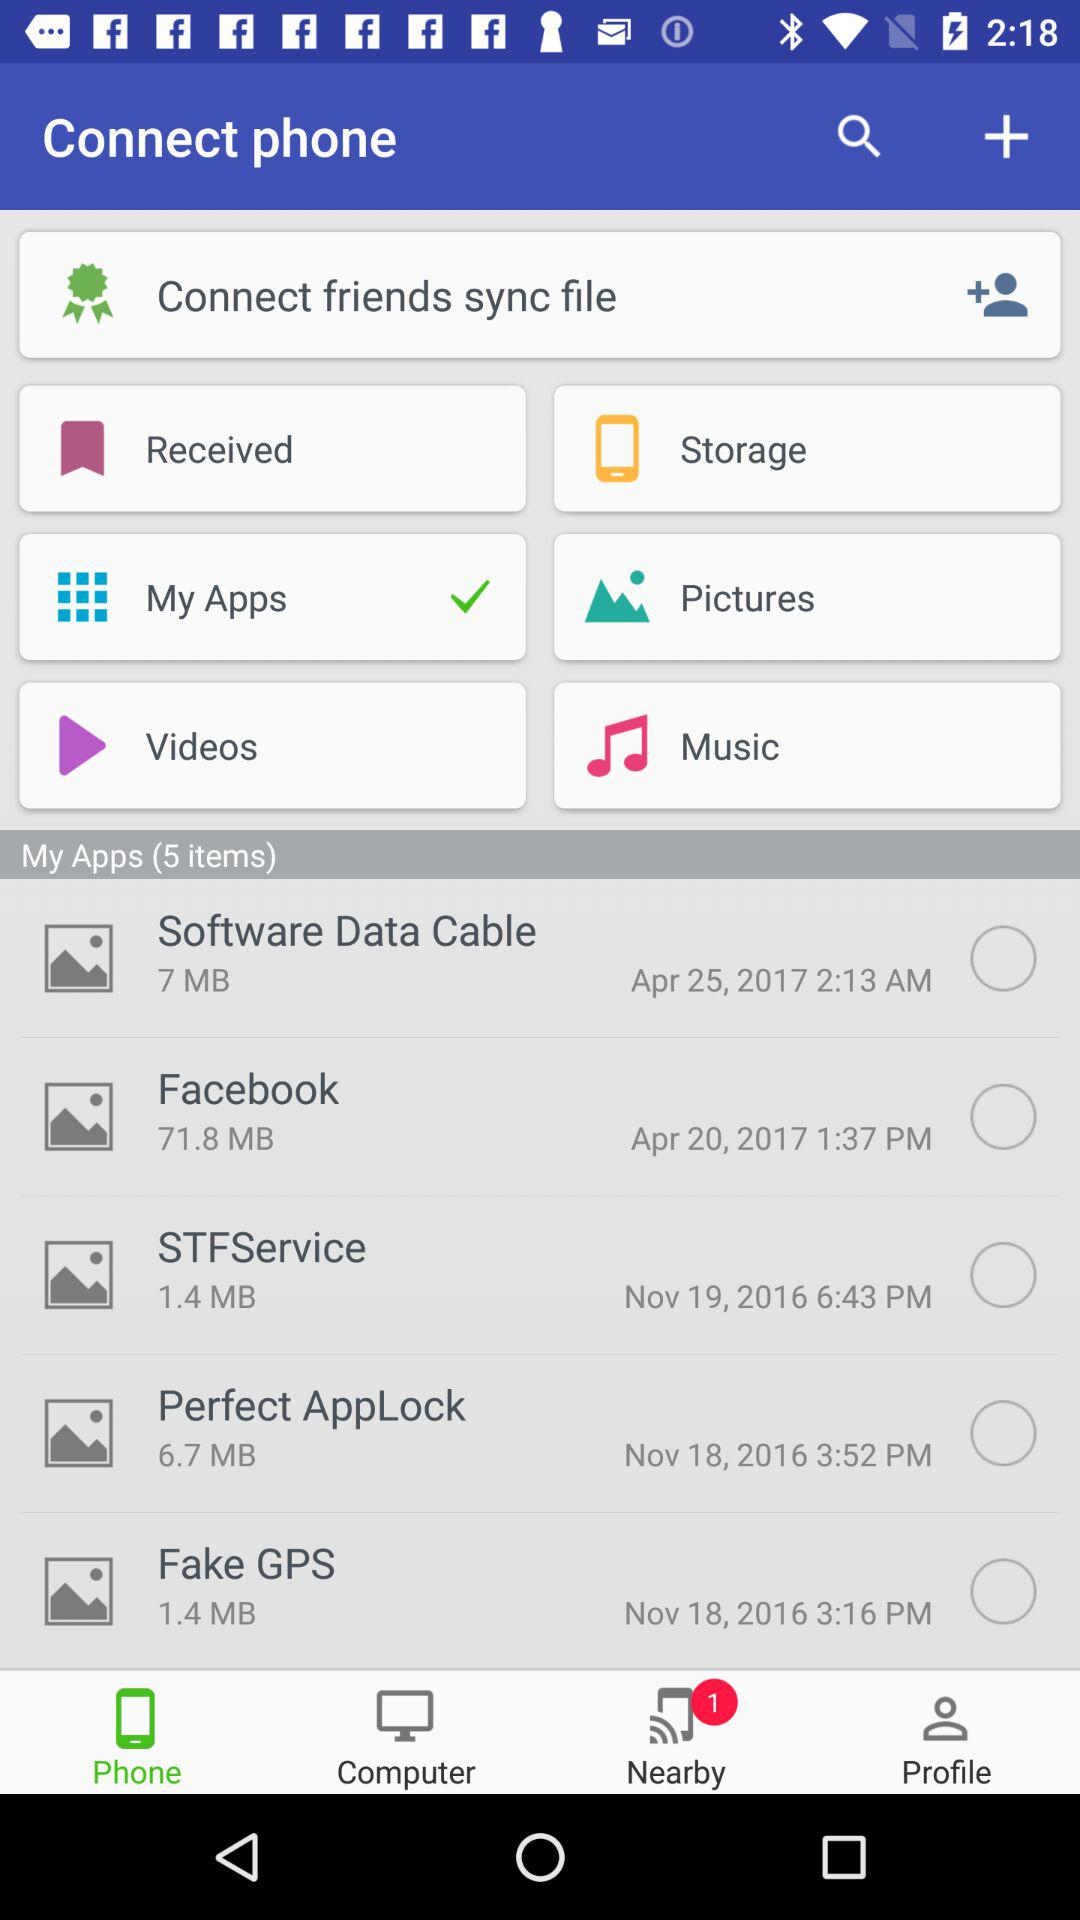How many apps are there in the My Apps section?
Answer the question using a single word or phrase. 5 